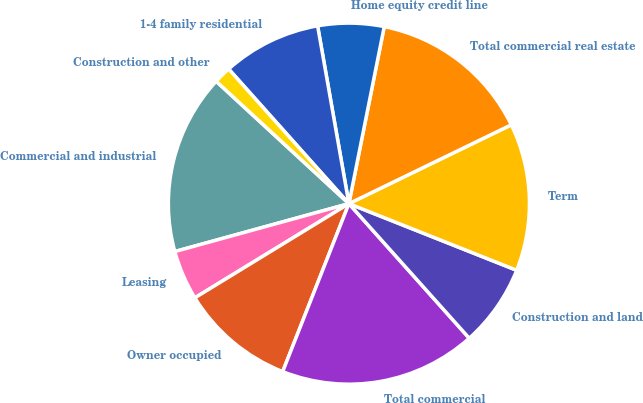Convert chart to OTSL. <chart><loc_0><loc_0><loc_500><loc_500><pie_chart><fcel>Commercial and industrial<fcel>Leasing<fcel>Owner occupied<fcel>Total commercial<fcel>Construction and land<fcel>Term<fcel>Total commercial real estate<fcel>Home equity credit line<fcel>1-4 family residential<fcel>Construction and other<nl><fcel>16.13%<fcel>4.46%<fcel>10.29%<fcel>17.59%<fcel>7.37%<fcel>13.21%<fcel>14.67%<fcel>5.91%<fcel>8.83%<fcel>1.54%<nl></chart> 